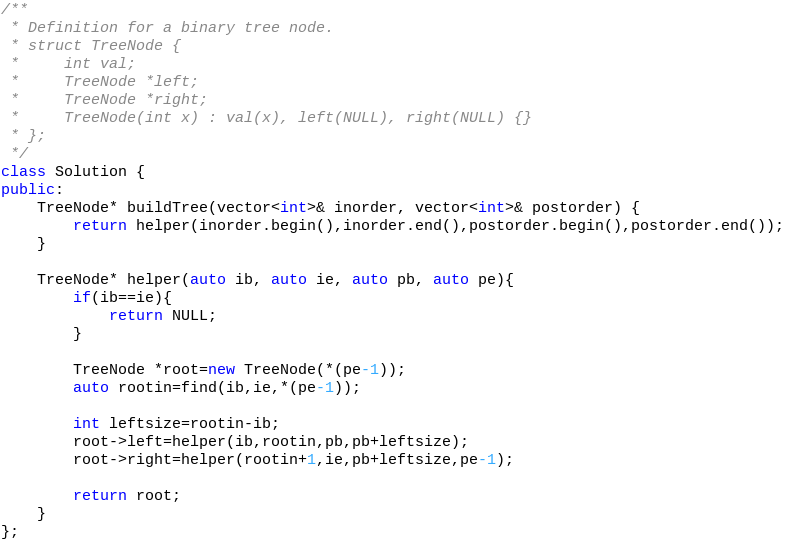<code> <loc_0><loc_0><loc_500><loc_500><_C++_>/**
 * Definition for a binary tree node.
 * struct TreeNode {
 *     int val;
 *     TreeNode *left;
 *     TreeNode *right;
 *     TreeNode(int x) : val(x), left(NULL), right(NULL) {}
 * };
 */
class Solution {
public:
    TreeNode* buildTree(vector<int>& inorder, vector<int>& postorder) {
        return helper(inorder.begin(),inorder.end(),postorder.begin(),postorder.end());
    }
    
    TreeNode* helper(auto ib, auto ie, auto pb, auto pe){
        if(ib==ie){
            return NULL;
        }
        
        TreeNode *root=new TreeNode(*(pe-1));
        auto rootin=find(ib,ie,*(pe-1));
        
        int leftsize=rootin-ib;
        root->left=helper(ib,rootin,pb,pb+leftsize);
        root->right=helper(rootin+1,ie,pb+leftsize,pe-1);
        
        return root;
    }
};</code> 